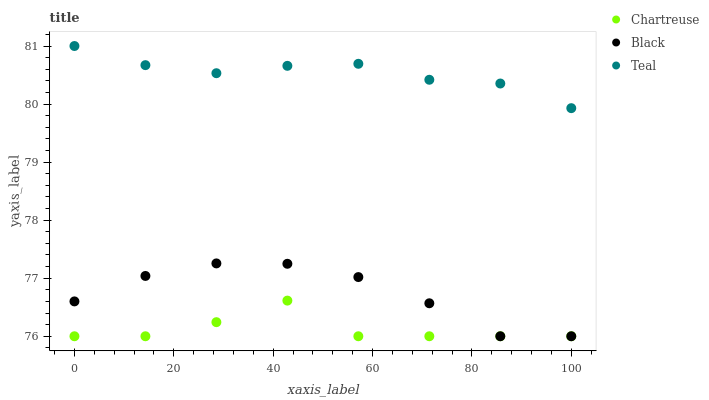Does Chartreuse have the minimum area under the curve?
Answer yes or no. Yes. Does Teal have the maximum area under the curve?
Answer yes or no. Yes. Does Black have the minimum area under the curve?
Answer yes or no. No. Does Black have the maximum area under the curve?
Answer yes or no. No. Is Teal the smoothest?
Answer yes or no. Yes. Is Chartreuse the roughest?
Answer yes or no. Yes. Is Black the smoothest?
Answer yes or no. No. Is Black the roughest?
Answer yes or no. No. Does Chartreuse have the lowest value?
Answer yes or no. Yes. Does Teal have the lowest value?
Answer yes or no. No. Does Teal have the highest value?
Answer yes or no. Yes. Does Black have the highest value?
Answer yes or no. No. Is Black less than Teal?
Answer yes or no. Yes. Is Teal greater than Chartreuse?
Answer yes or no. Yes. Does Black intersect Chartreuse?
Answer yes or no. Yes. Is Black less than Chartreuse?
Answer yes or no. No. Is Black greater than Chartreuse?
Answer yes or no. No. Does Black intersect Teal?
Answer yes or no. No. 